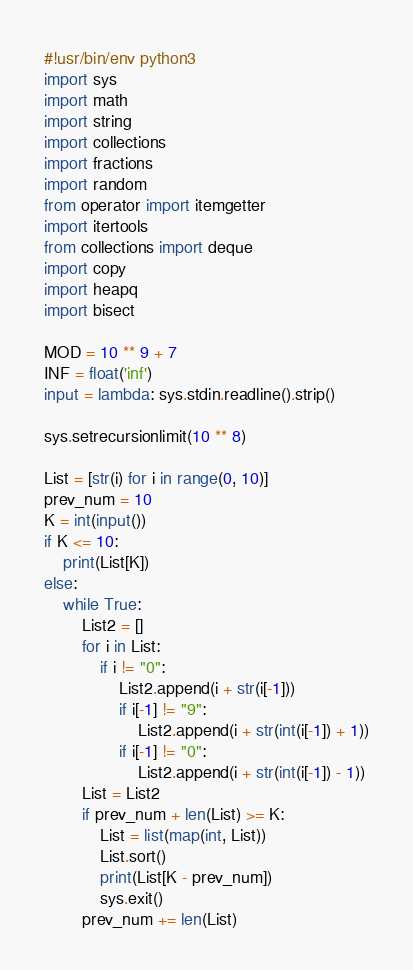Convert code to text. <code><loc_0><loc_0><loc_500><loc_500><_Python_>#!usr/bin/env python3
import sys
import math
import string
import collections
import fractions
import random
from operator import itemgetter
import itertools
from collections import deque
import copy
import heapq
import bisect

MOD = 10 ** 9 + 7
INF = float('inf')
input = lambda: sys.stdin.readline().strip()

sys.setrecursionlimit(10 ** 8)

List = [str(i) for i in range(0, 10)]
prev_num = 10
K = int(input())
if K <= 10:
    print(List[K])
else:
    while True:
        List2 = []
        for i in List:
            if i != "0":
                List2.append(i + str(i[-1]))
                if i[-1] != "9":
                    List2.append(i + str(int(i[-1]) + 1))
                if i[-1] != "0":
                    List2.append(i + str(int(i[-1]) - 1))
        List = List2
        if prev_num + len(List) >= K:
            List = list(map(int, List))
            List.sort()
            print(List[K - prev_num])
            sys.exit()
        prev_num += len(List)
</code> 